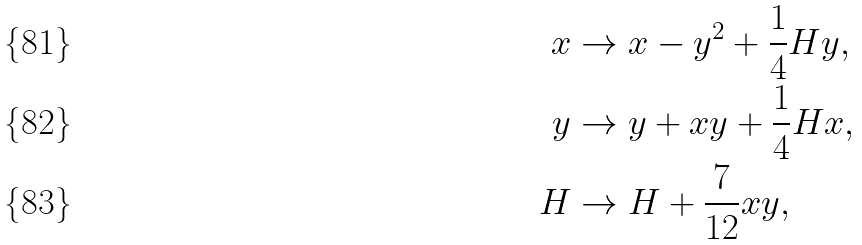<formula> <loc_0><loc_0><loc_500><loc_500>x & \rightarrow x - y ^ { 2 } + \frac { 1 } { 4 } H y , \\ y & \rightarrow y + x y + \frac { 1 } { 4 } H x , \\ H & \rightarrow H + \frac { 7 } { 1 2 } x y ,</formula> 